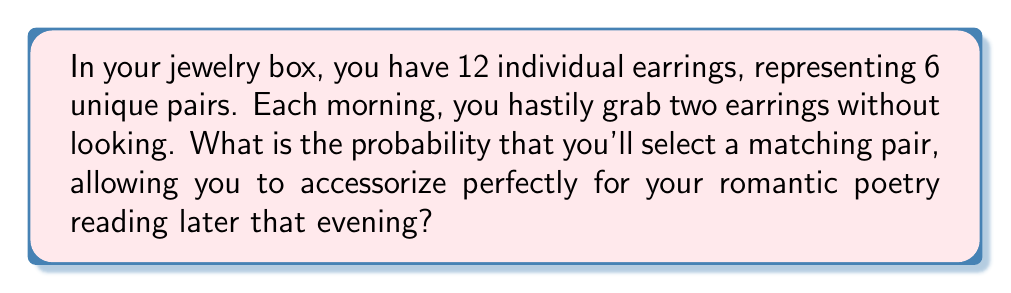Can you solve this math problem? Let's approach this step-by-step:

1) First, we need to calculate the total number of ways to select 2 earrings out of 12. This is given by the combination formula:

   $$\binom{12}{2} = \frac{12!}{2!(12-2)!} = \frac{12 \cdot 11}{2} = 66$$

2) Now, we need to calculate the number of ways to select a matching pair. There are 6 matching pairs, and we can select any one of these 6 pairs:

   $$\binom{6}{1} = 6$$

3) The probability is then the number of favorable outcomes divided by the total number of possible outcomes:

   $$P(\text{matching pair}) = \frac{\text{number of ways to select a matching pair}}{\text{total number of ways to select two earrings}}$$

   $$P(\text{matching pair}) = \frac{6}{66} = \frac{1}{11}$$

4) To express this as a percentage:

   $$\frac{1}{11} \approx 0.0909 = 9.09\%$$

Thus, there's approximately a 9.09% chance of selecting a matching pair of earrings.
Answer: $\frac{1}{11}$ or 9.09% 